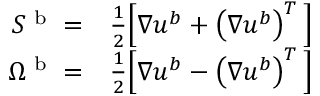<formula> <loc_0><loc_0><loc_500><loc_500>\begin{array} { r l } { S ^ { b } = } & \frac { 1 } { 2 } \left [ \nabla u ^ { b } + \left ( \nabla u ^ { b } \right ) ^ { T } \right ] } \\ { \Omega ^ { b } = } & \frac { 1 } { 2 } \left [ \nabla u ^ { b } - \left ( \nabla u ^ { b } \right ) ^ { T } \right ] } \end{array}</formula> 